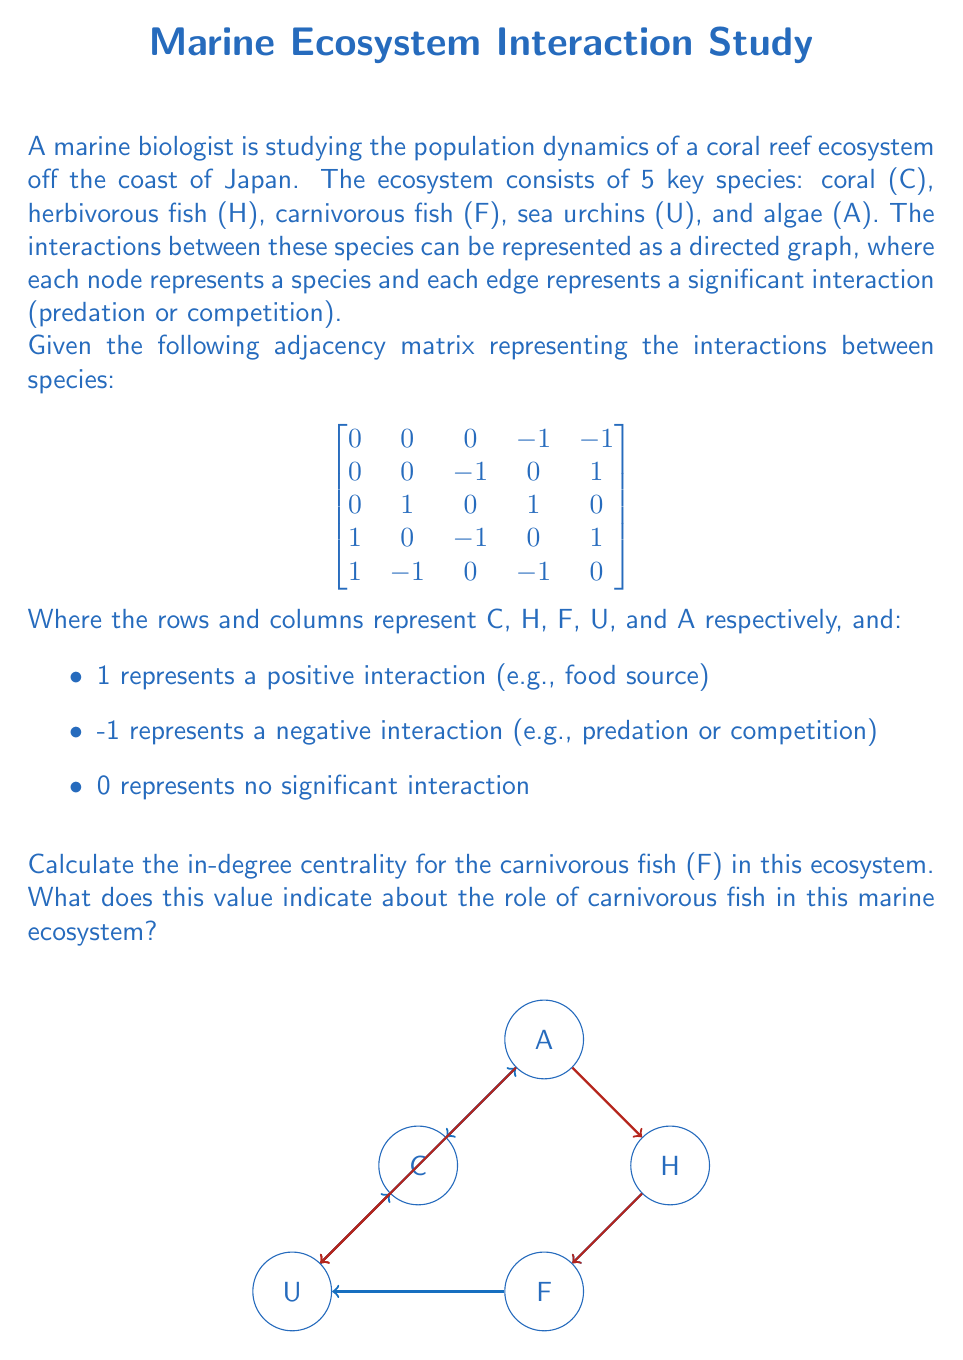Teach me how to tackle this problem. To calculate the in-degree centrality for the carnivorous fish (F), we need to follow these steps:

1. Understand the concept:
   In-degree centrality is the number of incoming edges to a node in a directed graph. In this ecosystem context, it represents the number of species that directly affect the carnivorous fish.

2. Identify the relevant column:
   The carnivorous fish (F) is represented by the third column in the adjacency matrix.

3. Count the non-zero entries in the column:
   Looking at the third column, we have:
   $$\begin{bmatrix}
   0 \\
   -1 \\
   0 \\
   -1 \\
   0
   \end{bmatrix}$$

4. Calculate the in-degree:
   There are two non-zero entries in this column: -1 for herbivorous fish (H) and -1 for sea urchins (U).
   Therefore, the in-degree centrality for carnivorous fish is 2.

5. Interpret the result:
   An in-degree centrality of 2 indicates that carnivorous fish are directly affected by two other species in this ecosystem. The negative values in the matrix suggest that these interactions are predatory or competitive.

   This value suggests that carnivorous fish play a significant role in the food web, being preyed upon or competing with two other species. It also implies that changes in the populations of herbivorous fish and sea urchins could have direct impacts on the carnivorous fish population.

   In the context of Japanese marine conservation, understanding these interactions is crucial for maintaining biodiversity and ecosystem balance in coral reef systems.
Answer: 2; indicates carnivorous fish are directly affected by two species, playing a key role in the ecosystem's food web. 